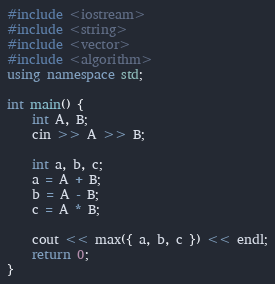Convert code to text. <code><loc_0><loc_0><loc_500><loc_500><_C++_>#include <iostream>
#include <string>
#include <vector>
#include <algorithm>
using namespace std;

int main() {
	int A, B;
	cin >> A >> B;

	int a, b, c;
	a = A + B;
	b = A - B;
	c = A * B;
	
	cout << max({ a, b, c }) << endl;
	return 0;
}</code> 